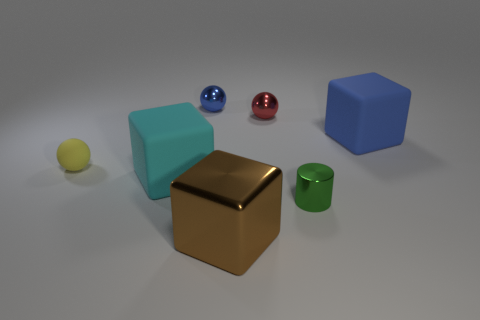Add 3 small shiny cylinders. How many objects exist? 10 Subtract all cylinders. How many objects are left? 6 Add 7 matte cubes. How many matte cubes are left? 9 Add 6 large gray metal cylinders. How many large gray metal cylinders exist? 6 Subtract 1 red spheres. How many objects are left? 6 Subtract all large blue objects. Subtract all blue things. How many objects are left? 4 